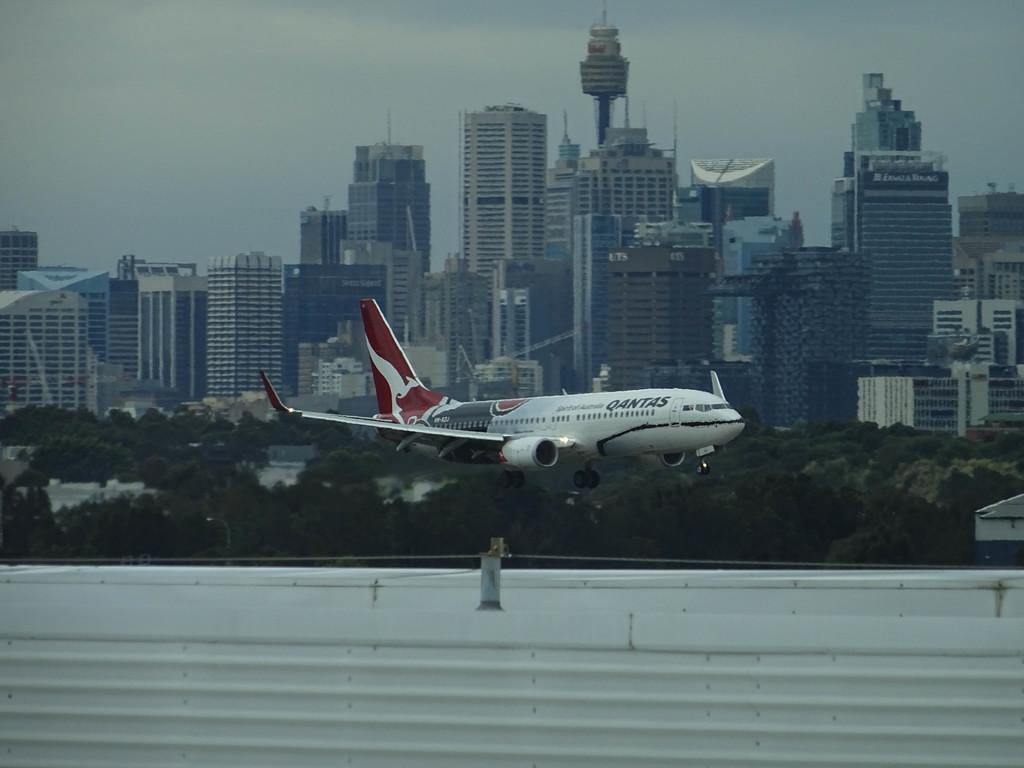What is the main subject of the image? The main subject of the image is an airplane. What is the airplane doing in the image? The airplane is flying in the image. What can be seen in the background of the image? There are buildings and trees visible in the background of the image. What type of property is being sold in the image? There is no property being sold in the image; it features an airplane flying with buildings and trees in the background. Can you tell me how many balloons are attached to the airplane in the image? There are no balloons attached to the airplane in the image. 